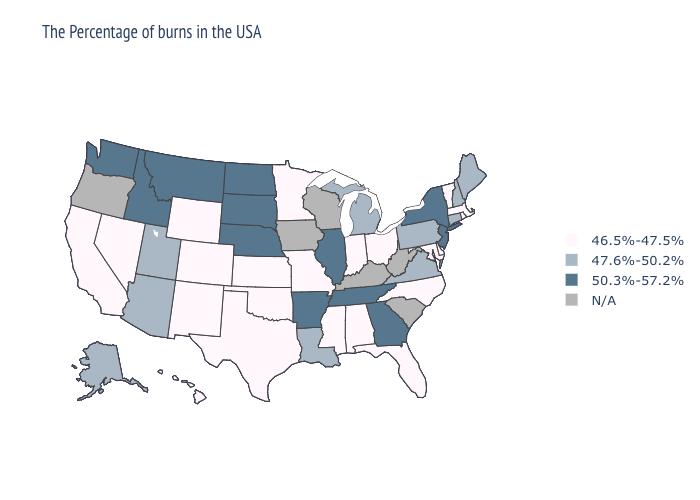What is the lowest value in the Northeast?
Quick response, please. 46.5%-47.5%. What is the value of New Mexico?
Keep it brief. 46.5%-47.5%. Name the states that have a value in the range 50.3%-57.2%?
Be succinct. New York, New Jersey, Georgia, Tennessee, Illinois, Arkansas, Nebraska, South Dakota, North Dakota, Montana, Idaho, Washington. Does New Jersey have the highest value in the Northeast?
Answer briefly. Yes. Name the states that have a value in the range 46.5%-47.5%?
Quick response, please. Massachusetts, Rhode Island, Vermont, Delaware, Maryland, North Carolina, Ohio, Florida, Indiana, Alabama, Mississippi, Missouri, Minnesota, Kansas, Oklahoma, Texas, Wyoming, Colorado, New Mexico, Nevada, California, Hawaii. How many symbols are there in the legend?
Answer briefly. 4. Among the states that border Delaware , does New Jersey have the lowest value?
Short answer required. No. What is the value of Nevada?
Answer briefly. 46.5%-47.5%. What is the highest value in the South ?
Concise answer only. 50.3%-57.2%. Does North Dakota have the highest value in the USA?
Quick response, please. Yes. Among the states that border Rhode Island , which have the highest value?
Quick response, please. Connecticut. What is the value of Louisiana?
Give a very brief answer. 47.6%-50.2%. Name the states that have a value in the range N/A?
Short answer required. South Carolina, West Virginia, Kentucky, Wisconsin, Iowa, Oregon. What is the value of Idaho?
Concise answer only. 50.3%-57.2%. What is the highest value in the South ?
Write a very short answer. 50.3%-57.2%. 